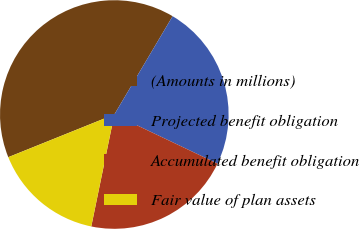Convert chart to OTSL. <chart><loc_0><loc_0><loc_500><loc_500><pie_chart><fcel>(Amounts in millions)<fcel>Projected benefit obligation<fcel>Accumulated benefit obligation<fcel>Fair value of plan assets<nl><fcel>39.61%<fcel>23.55%<fcel>21.16%<fcel>15.68%<nl></chart> 